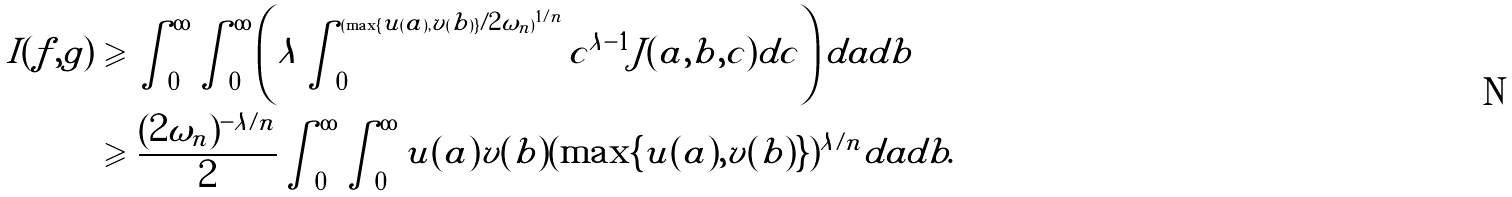Convert formula to latex. <formula><loc_0><loc_0><loc_500><loc_500>I ( f , g ) & \geqslant \int _ { 0 } ^ { \infty } \int _ { 0 } ^ { \infty } \left ( \lambda \int _ { 0 } ^ { ( \max \{ u ( a ) , v ( b ) \} / 2 \omega _ { n } ) ^ { 1 / n } } c ^ { \lambda - 1 } J ( a , b , c ) d c \right ) d a d b \\ & \geqslant \frac { ( 2 \omega _ { n } ) ^ { - \lambda / n } } 2 \int _ { 0 } ^ { \infty } \int _ { 0 } ^ { \infty } u ( a ) v ( b ) ( \max \{ u ( a ) , v ( b ) \} ) ^ { \lambda / n } d a d b .</formula> 